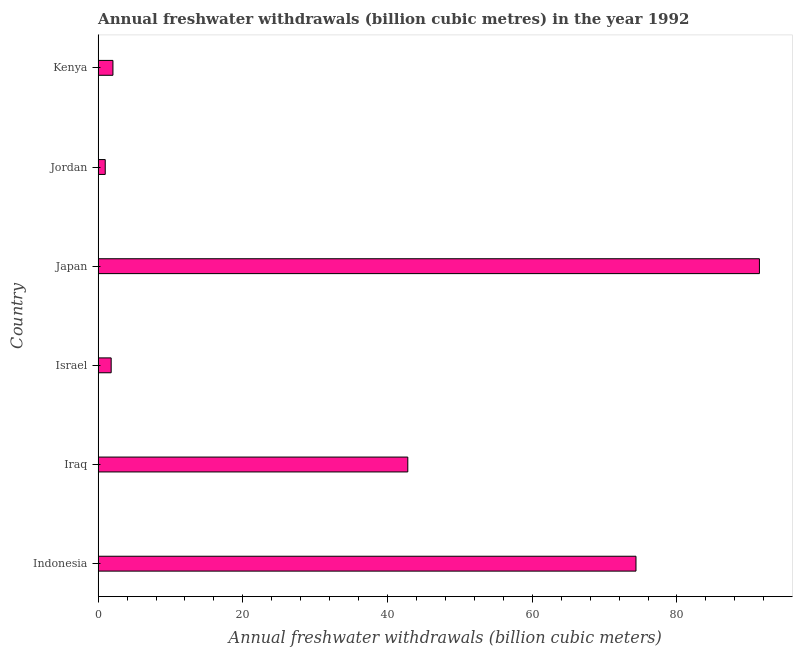Does the graph contain any zero values?
Keep it short and to the point. No. Does the graph contain grids?
Your answer should be compact. No. What is the title of the graph?
Offer a terse response. Annual freshwater withdrawals (billion cubic metres) in the year 1992. What is the label or title of the X-axis?
Provide a short and direct response. Annual freshwater withdrawals (billion cubic meters). What is the annual freshwater withdrawals in Iraq?
Provide a short and direct response. 42.8. Across all countries, what is the maximum annual freshwater withdrawals?
Offer a very short reply. 91.4. In which country was the annual freshwater withdrawals minimum?
Your answer should be compact. Jordan. What is the sum of the annual freshwater withdrawals?
Your answer should be compact. 213.38. What is the difference between the annual freshwater withdrawals in Indonesia and Israel?
Offer a very short reply. 72.54. What is the average annual freshwater withdrawals per country?
Make the answer very short. 35.56. What is the median annual freshwater withdrawals?
Your answer should be very brief. 22.42. What is the ratio of the annual freshwater withdrawals in Indonesia to that in Kenya?
Keep it short and to the point. 36.28. Is the difference between the annual freshwater withdrawals in Iraq and Kenya greater than the difference between any two countries?
Make the answer very short. No. What is the difference between the highest and the second highest annual freshwater withdrawals?
Provide a short and direct response. 17.06. Is the sum of the annual freshwater withdrawals in Iraq and Kenya greater than the maximum annual freshwater withdrawals across all countries?
Provide a short and direct response. No. What is the difference between the highest and the lowest annual freshwater withdrawals?
Offer a terse response. 90.42. In how many countries, is the annual freshwater withdrawals greater than the average annual freshwater withdrawals taken over all countries?
Make the answer very short. 3. Are all the bars in the graph horizontal?
Your response must be concise. Yes. How many countries are there in the graph?
Provide a succinct answer. 6. What is the difference between two consecutive major ticks on the X-axis?
Provide a succinct answer. 20. Are the values on the major ticks of X-axis written in scientific E-notation?
Keep it short and to the point. No. What is the Annual freshwater withdrawals (billion cubic meters) in Indonesia?
Provide a short and direct response. 74.34. What is the Annual freshwater withdrawals (billion cubic meters) in Iraq?
Ensure brevity in your answer.  42.8. What is the Annual freshwater withdrawals (billion cubic meters) in Israel?
Offer a terse response. 1.8. What is the Annual freshwater withdrawals (billion cubic meters) of Japan?
Your response must be concise. 91.4. What is the Annual freshwater withdrawals (billion cubic meters) in Jordan?
Provide a short and direct response. 0.98. What is the Annual freshwater withdrawals (billion cubic meters) in Kenya?
Your answer should be compact. 2.05. What is the difference between the Annual freshwater withdrawals (billion cubic meters) in Indonesia and Iraq?
Provide a short and direct response. 31.54. What is the difference between the Annual freshwater withdrawals (billion cubic meters) in Indonesia and Israel?
Provide a succinct answer. 72.54. What is the difference between the Annual freshwater withdrawals (billion cubic meters) in Indonesia and Japan?
Offer a very short reply. -17.06. What is the difference between the Annual freshwater withdrawals (billion cubic meters) in Indonesia and Jordan?
Keep it short and to the point. 73.36. What is the difference between the Annual freshwater withdrawals (billion cubic meters) in Indonesia and Kenya?
Provide a succinct answer. 72.29. What is the difference between the Annual freshwater withdrawals (billion cubic meters) in Iraq and Israel?
Make the answer very short. 41. What is the difference between the Annual freshwater withdrawals (billion cubic meters) in Iraq and Japan?
Give a very brief answer. -48.6. What is the difference between the Annual freshwater withdrawals (billion cubic meters) in Iraq and Jordan?
Offer a terse response. 41.82. What is the difference between the Annual freshwater withdrawals (billion cubic meters) in Iraq and Kenya?
Make the answer very short. 40.75. What is the difference between the Annual freshwater withdrawals (billion cubic meters) in Israel and Japan?
Your answer should be compact. -89.6. What is the difference between the Annual freshwater withdrawals (billion cubic meters) in Israel and Jordan?
Your response must be concise. 0.82. What is the difference between the Annual freshwater withdrawals (billion cubic meters) in Israel and Kenya?
Give a very brief answer. -0.24. What is the difference between the Annual freshwater withdrawals (billion cubic meters) in Japan and Jordan?
Give a very brief answer. 90.42. What is the difference between the Annual freshwater withdrawals (billion cubic meters) in Japan and Kenya?
Ensure brevity in your answer.  89.35. What is the difference between the Annual freshwater withdrawals (billion cubic meters) in Jordan and Kenya?
Ensure brevity in your answer.  -1.06. What is the ratio of the Annual freshwater withdrawals (billion cubic meters) in Indonesia to that in Iraq?
Ensure brevity in your answer.  1.74. What is the ratio of the Annual freshwater withdrawals (billion cubic meters) in Indonesia to that in Israel?
Provide a short and direct response. 41.21. What is the ratio of the Annual freshwater withdrawals (billion cubic meters) in Indonesia to that in Japan?
Your answer should be very brief. 0.81. What is the ratio of the Annual freshwater withdrawals (billion cubic meters) in Indonesia to that in Jordan?
Give a very brief answer. 75.55. What is the ratio of the Annual freshwater withdrawals (billion cubic meters) in Indonesia to that in Kenya?
Keep it short and to the point. 36.28. What is the ratio of the Annual freshwater withdrawals (billion cubic meters) in Iraq to that in Israel?
Offer a terse response. 23.73. What is the ratio of the Annual freshwater withdrawals (billion cubic meters) in Iraq to that in Japan?
Keep it short and to the point. 0.47. What is the ratio of the Annual freshwater withdrawals (billion cubic meters) in Iraq to that in Jordan?
Provide a short and direct response. 43.5. What is the ratio of the Annual freshwater withdrawals (billion cubic meters) in Iraq to that in Kenya?
Ensure brevity in your answer.  20.89. What is the ratio of the Annual freshwater withdrawals (billion cubic meters) in Israel to that in Jordan?
Provide a short and direct response. 1.83. What is the ratio of the Annual freshwater withdrawals (billion cubic meters) in Israel to that in Kenya?
Make the answer very short. 0.88. What is the ratio of the Annual freshwater withdrawals (billion cubic meters) in Japan to that in Jordan?
Make the answer very short. 92.89. What is the ratio of the Annual freshwater withdrawals (billion cubic meters) in Japan to that in Kenya?
Keep it short and to the point. 44.61. What is the ratio of the Annual freshwater withdrawals (billion cubic meters) in Jordan to that in Kenya?
Provide a succinct answer. 0.48. 